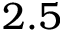<formula> <loc_0><loc_0><loc_500><loc_500>2 . 5</formula> 